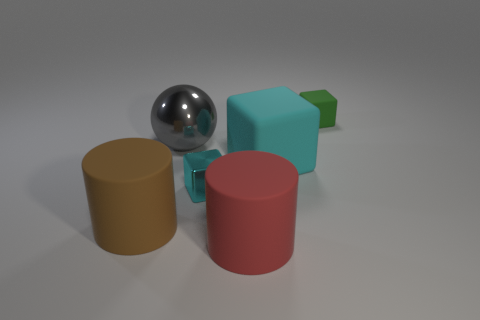Subtract 1 blocks. How many blocks are left? 2 Add 4 big objects. How many objects exist? 10 Subtract all balls. How many objects are left? 5 Subtract 1 cyan cubes. How many objects are left? 5 Subtract all small matte objects. Subtract all gray shiny things. How many objects are left? 4 Add 3 large shiny spheres. How many large shiny spheres are left? 4 Add 6 shiny balls. How many shiny balls exist? 7 